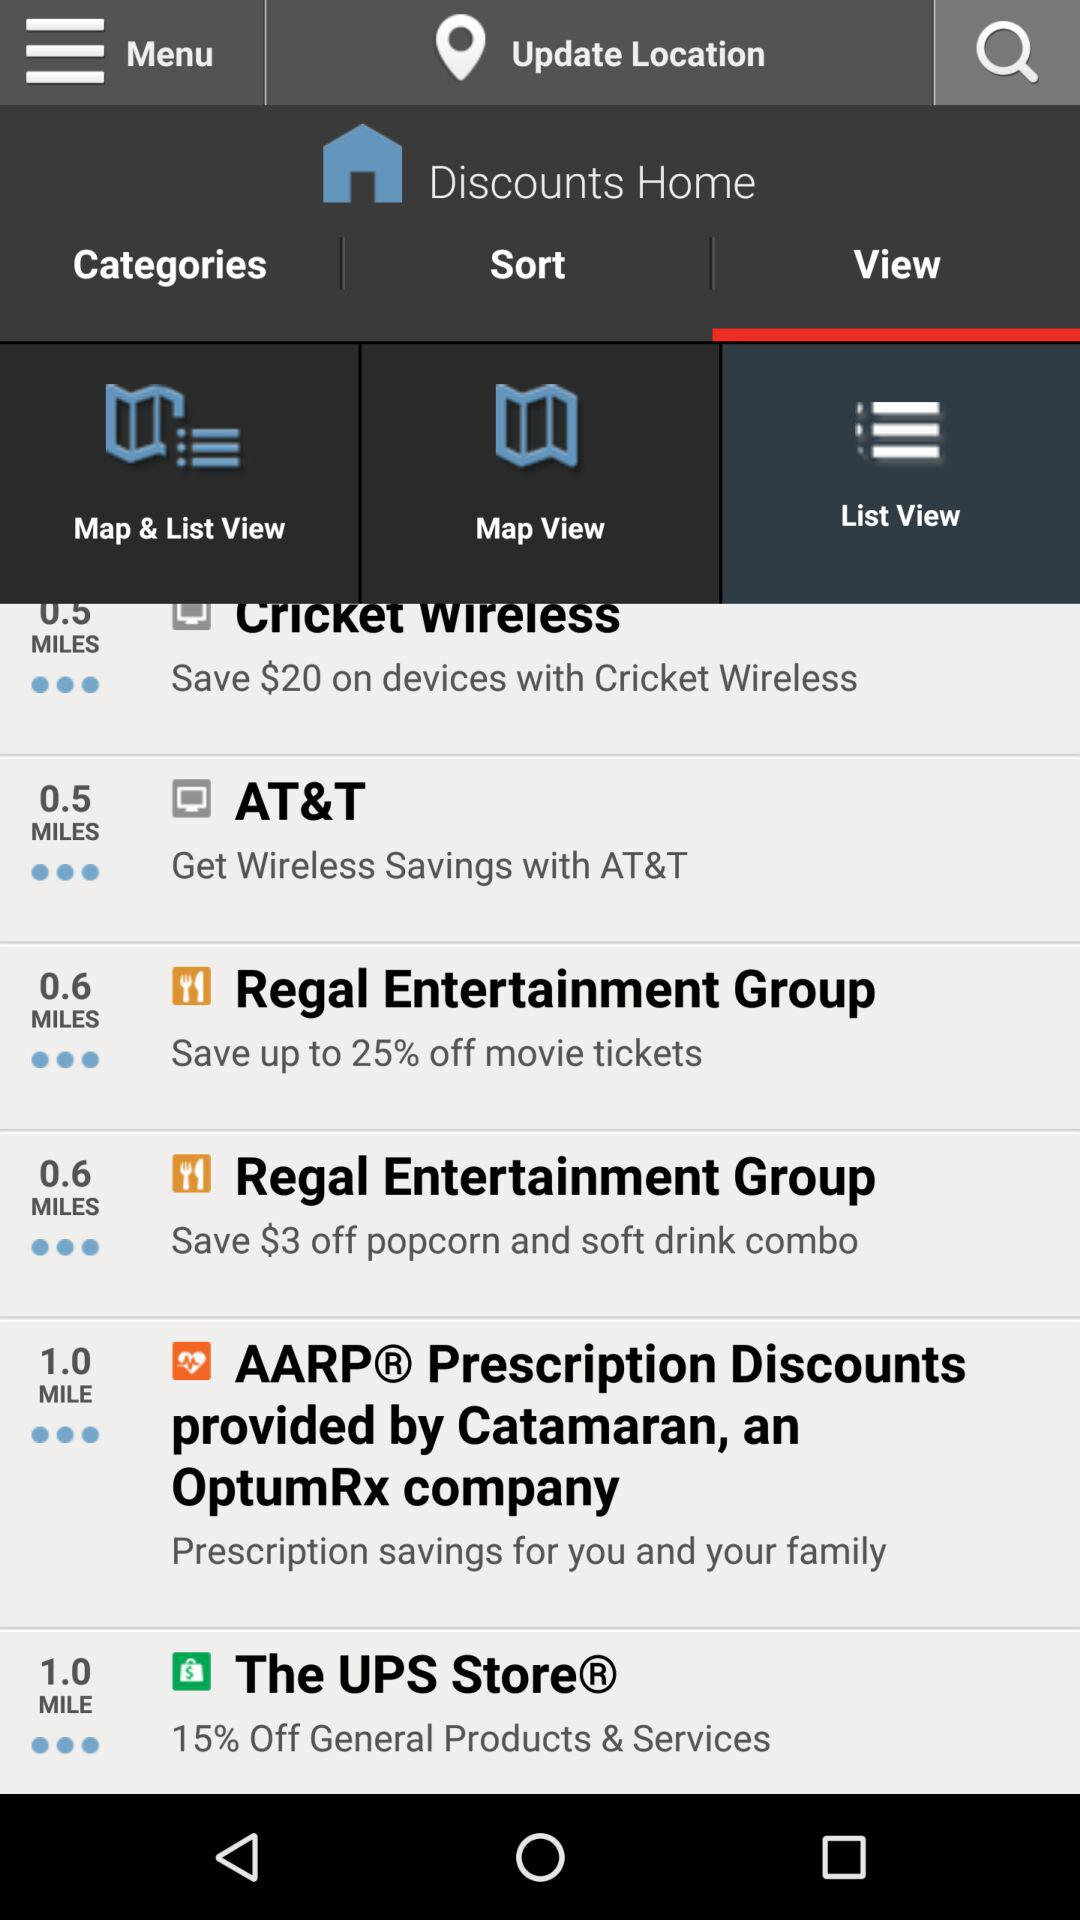Up to what percentage can be saved on movie tickets at "Regal Entertainment Group"? At "Regal Entertainment Group", up to 25% can be saved on movie tickets. 